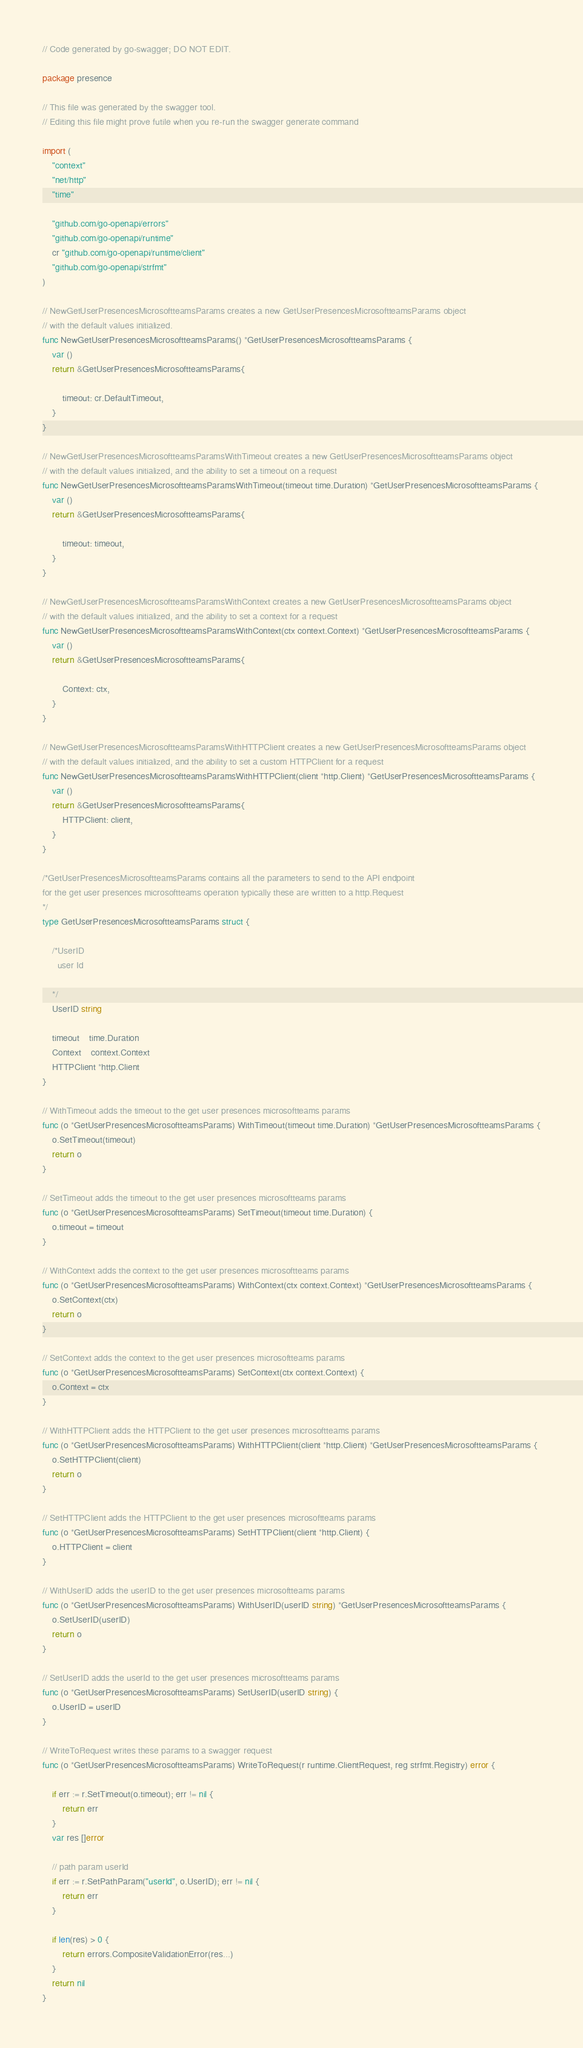<code> <loc_0><loc_0><loc_500><loc_500><_Go_>// Code generated by go-swagger; DO NOT EDIT.

package presence

// This file was generated by the swagger tool.
// Editing this file might prove futile when you re-run the swagger generate command

import (
	"context"
	"net/http"
	"time"

	"github.com/go-openapi/errors"
	"github.com/go-openapi/runtime"
	cr "github.com/go-openapi/runtime/client"
	"github.com/go-openapi/strfmt"
)

// NewGetUserPresencesMicrosoftteamsParams creates a new GetUserPresencesMicrosoftteamsParams object
// with the default values initialized.
func NewGetUserPresencesMicrosoftteamsParams() *GetUserPresencesMicrosoftteamsParams {
	var ()
	return &GetUserPresencesMicrosoftteamsParams{

		timeout: cr.DefaultTimeout,
	}
}

// NewGetUserPresencesMicrosoftteamsParamsWithTimeout creates a new GetUserPresencesMicrosoftteamsParams object
// with the default values initialized, and the ability to set a timeout on a request
func NewGetUserPresencesMicrosoftteamsParamsWithTimeout(timeout time.Duration) *GetUserPresencesMicrosoftteamsParams {
	var ()
	return &GetUserPresencesMicrosoftteamsParams{

		timeout: timeout,
	}
}

// NewGetUserPresencesMicrosoftteamsParamsWithContext creates a new GetUserPresencesMicrosoftteamsParams object
// with the default values initialized, and the ability to set a context for a request
func NewGetUserPresencesMicrosoftteamsParamsWithContext(ctx context.Context) *GetUserPresencesMicrosoftteamsParams {
	var ()
	return &GetUserPresencesMicrosoftteamsParams{

		Context: ctx,
	}
}

// NewGetUserPresencesMicrosoftteamsParamsWithHTTPClient creates a new GetUserPresencesMicrosoftteamsParams object
// with the default values initialized, and the ability to set a custom HTTPClient for a request
func NewGetUserPresencesMicrosoftteamsParamsWithHTTPClient(client *http.Client) *GetUserPresencesMicrosoftteamsParams {
	var ()
	return &GetUserPresencesMicrosoftteamsParams{
		HTTPClient: client,
	}
}

/*GetUserPresencesMicrosoftteamsParams contains all the parameters to send to the API endpoint
for the get user presences microsoftteams operation typically these are written to a http.Request
*/
type GetUserPresencesMicrosoftteamsParams struct {

	/*UserID
	  user Id

	*/
	UserID string

	timeout    time.Duration
	Context    context.Context
	HTTPClient *http.Client
}

// WithTimeout adds the timeout to the get user presences microsoftteams params
func (o *GetUserPresencesMicrosoftteamsParams) WithTimeout(timeout time.Duration) *GetUserPresencesMicrosoftteamsParams {
	o.SetTimeout(timeout)
	return o
}

// SetTimeout adds the timeout to the get user presences microsoftteams params
func (o *GetUserPresencesMicrosoftteamsParams) SetTimeout(timeout time.Duration) {
	o.timeout = timeout
}

// WithContext adds the context to the get user presences microsoftteams params
func (o *GetUserPresencesMicrosoftteamsParams) WithContext(ctx context.Context) *GetUserPresencesMicrosoftteamsParams {
	o.SetContext(ctx)
	return o
}

// SetContext adds the context to the get user presences microsoftteams params
func (o *GetUserPresencesMicrosoftteamsParams) SetContext(ctx context.Context) {
	o.Context = ctx
}

// WithHTTPClient adds the HTTPClient to the get user presences microsoftteams params
func (o *GetUserPresencesMicrosoftteamsParams) WithHTTPClient(client *http.Client) *GetUserPresencesMicrosoftteamsParams {
	o.SetHTTPClient(client)
	return o
}

// SetHTTPClient adds the HTTPClient to the get user presences microsoftteams params
func (o *GetUserPresencesMicrosoftteamsParams) SetHTTPClient(client *http.Client) {
	o.HTTPClient = client
}

// WithUserID adds the userID to the get user presences microsoftteams params
func (o *GetUserPresencesMicrosoftteamsParams) WithUserID(userID string) *GetUserPresencesMicrosoftteamsParams {
	o.SetUserID(userID)
	return o
}

// SetUserID adds the userId to the get user presences microsoftteams params
func (o *GetUserPresencesMicrosoftteamsParams) SetUserID(userID string) {
	o.UserID = userID
}

// WriteToRequest writes these params to a swagger request
func (o *GetUserPresencesMicrosoftteamsParams) WriteToRequest(r runtime.ClientRequest, reg strfmt.Registry) error {

	if err := r.SetTimeout(o.timeout); err != nil {
		return err
	}
	var res []error

	// path param userId
	if err := r.SetPathParam("userId", o.UserID); err != nil {
		return err
	}

	if len(res) > 0 {
		return errors.CompositeValidationError(res...)
	}
	return nil
}
</code> 